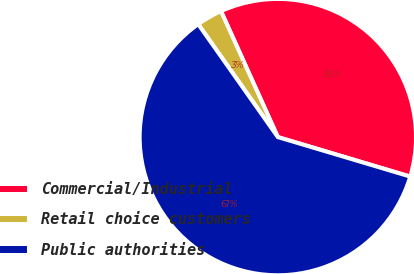<chart> <loc_0><loc_0><loc_500><loc_500><pie_chart><fcel>Commercial/Industrial<fcel>Retail choice customers<fcel>Public authorities<nl><fcel>36.36%<fcel>3.03%<fcel>60.61%<nl></chart> 